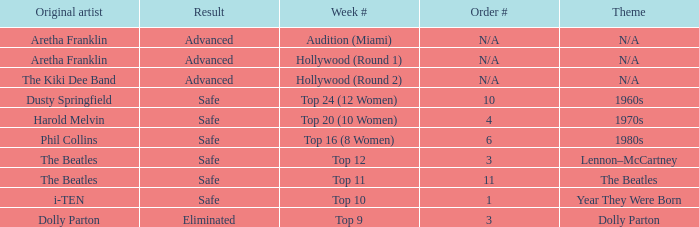What is the week number that has Dolly Parton as the theme? Top 9. 